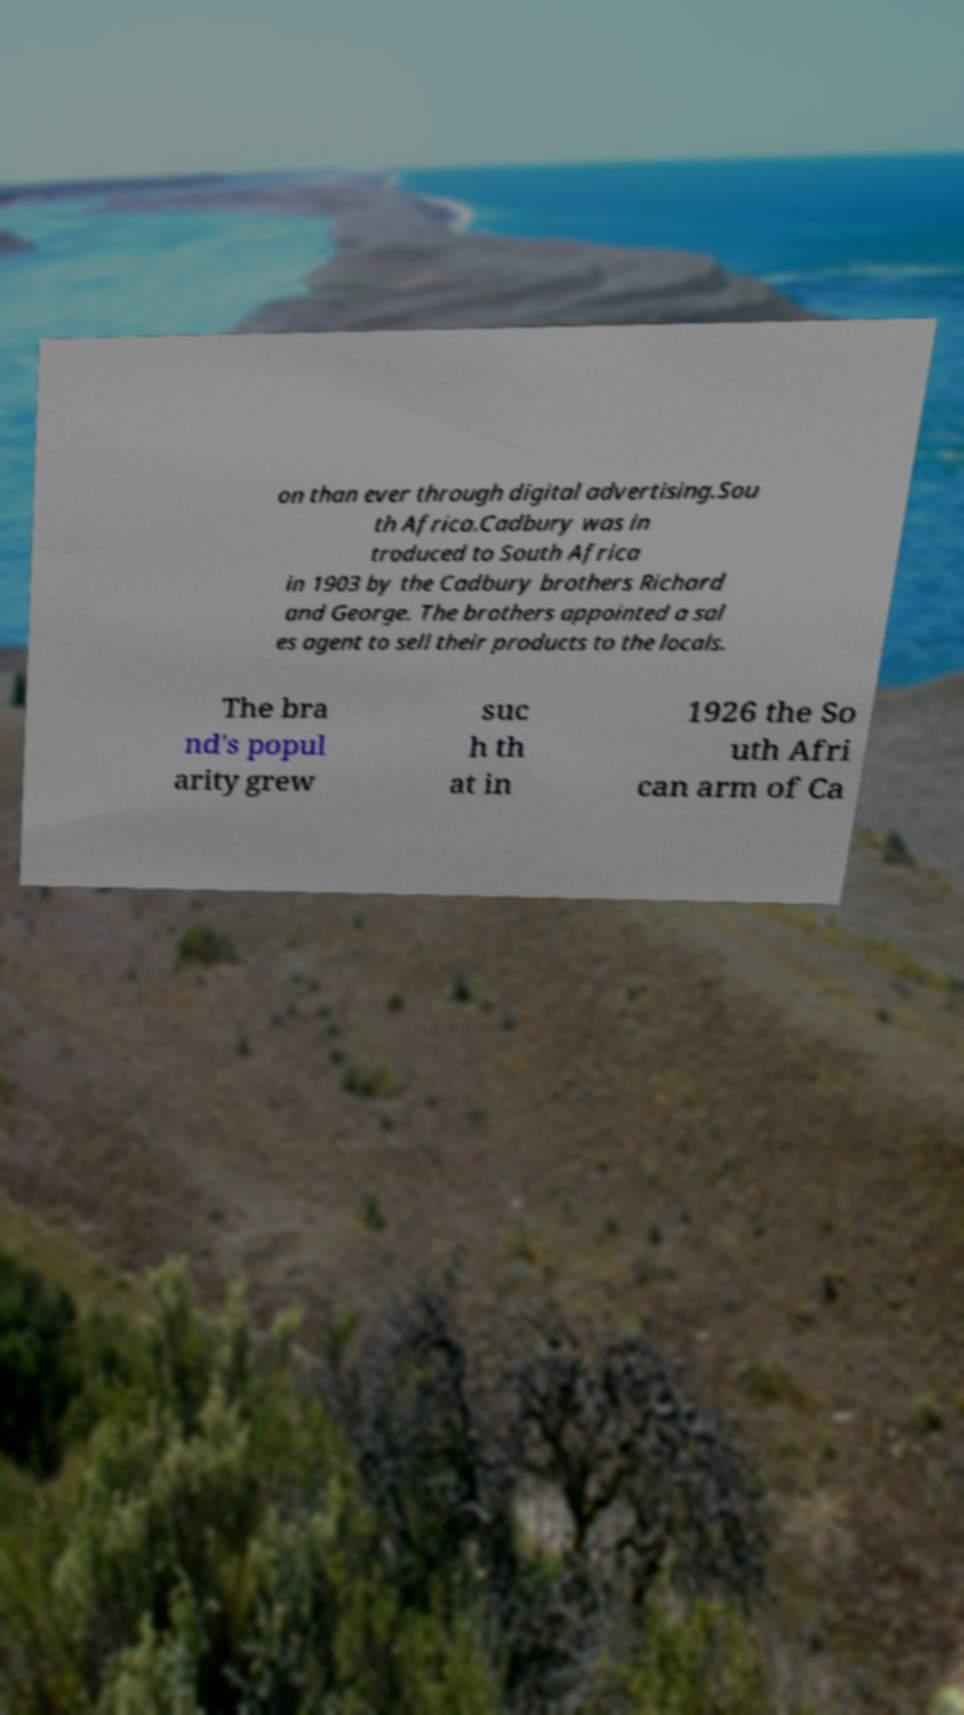Could you extract and type out the text from this image? on than ever through digital advertising.Sou th Africa.Cadbury was in troduced to South Africa in 1903 by the Cadbury brothers Richard and George. The brothers appointed a sal es agent to sell their products to the locals. The bra nd's popul arity grew suc h th at in 1926 the So uth Afri can arm of Ca 